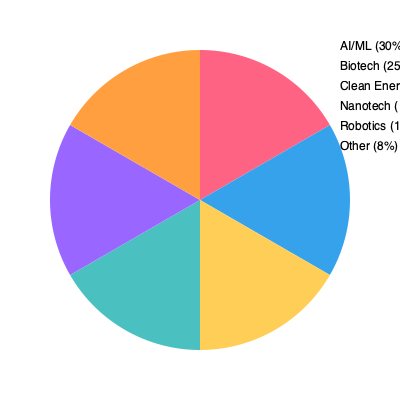Given the pie chart showing the distribution of research focus areas in university-industry partnerships, which two areas combined account for more than half of all collaborations, and what percentage do they represent together? To answer this question, we need to follow these steps:

1. Identify the two largest segments in the pie chart.
2. Add their percentages together.
3. Verify if the sum exceeds 50%.

From the pie chart, we can see:

1. The two largest segments are:
   - AI/ML: 30%
   - Biotech: 25%

2. Adding these percentages:
   $30\% + 25\% = 55\%$

3. Verification:
   55% is indeed greater than 50%, so these two areas combined account for more than half of all collaborations.

Therefore, AI/ML and Biotech together represent 55% of all university-industry research partnerships.
Answer: AI/ML and Biotech, 55% 